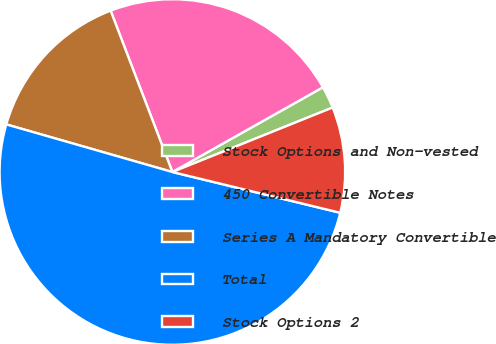<chart> <loc_0><loc_0><loc_500><loc_500><pie_chart><fcel>Stock Options and Non-vested<fcel>450 Convertible Notes<fcel>Series A Mandatory Convertible<fcel>Total<fcel>Stock Options 2<nl><fcel>2.07%<fcel>22.66%<fcel>14.74%<fcel>50.65%<fcel>9.88%<nl></chart> 